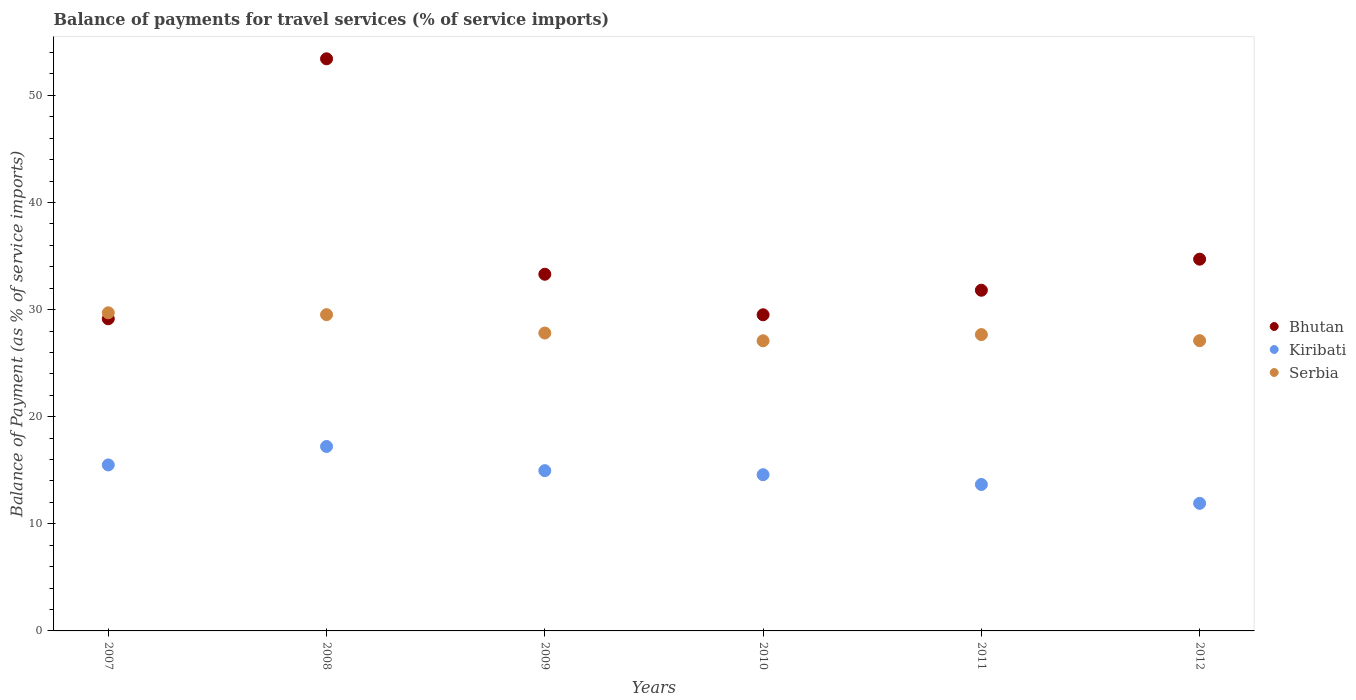How many different coloured dotlines are there?
Your answer should be compact. 3. What is the balance of payments for travel services in Serbia in 2010?
Your answer should be compact. 27.09. Across all years, what is the maximum balance of payments for travel services in Kiribati?
Provide a succinct answer. 17.22. Across all years, what is the minimum balance of payments for travel services in Kiribati?
Your answer should be very brief. 11.91. In which year was the balance of payments for travel services in Bhutan maximum?
Make the answer very short. 2008. What is the total balance of payments for travel services in Bhutan in the graph?
Provide a short and direct response. 211.89. What is the difference between the balance of payments for travel services in Serbia in 2007 and that in 2011?
Keep it short and to the point. 2.04. What is the difference between the balance of payments for travel services in Serbia in 2010 and the balance of payments for travel services in Bhutan in 2008?
Your answer should be very brief. -26.33. What is the average balance of payments for travel services in Bhutan per year?
Offer a very short reply. 35.31. In the year 2009, what is the difference between the balance of payments for travel services in Serbia and balance of payments for travel services in Bhutan?
Make the answer very short. -5.49. What is the ratio of the balance of payments for travel services in Bhutan in 2007 to that in 2012?
Make the answer very short. 0.84. What is the difference between the highest and the second highest balance of payments for travel services in Serbia?
Your response must be concise. 0.17. What is the difference between the highest and the lowest balance of payments for travel services in Kiribati?
Keep it short and to the point. 5.31. In how many years, is the balance of payments for travel services in Serbia greater than the average balance of payments for travel services in Serbia taken over all years?
Your answer should be very brief. 2. Does the balance of payments for travel services in Serbia monotonically increase over the years?
Your response must be concise. No. Is the balance of payments for travel services in Bhutan strictly less than the balance of payments for travel services in Kiribati over the years?
Offer a very short reply. No. How many dotlines are there?
Make the answer very short. 3. What is the difference between two consecutive major ticks on the Y-axis?
Your answer should be very brief. 10. Where does the legend appear in the graph?
Keep it short and to the point. Center right. How are the legend labels stacked?
Provide a succinct answer. Vertical. What is the title of the graph?
Offer a very short reply. Balance of payments for travel services (% of service imports). What is the label or title of the Y-axis?
Your answer should be very brief. Balance of Payment (as % of service imports). What is the Balance of Payment (as % of service imports) of Bhutan in 2007?
Make the answer very short. 29.14. What is the Balance of Payment (as % of service imports) in Kiribati in 2007?
Keep it short and to the point. 15.5. What is the Balance of Payment (as % of service imports) of Serbia in 2007?
Keep it short and to the point. 29.7. What is the Balance of Payment (as % of service imports) of Bhutan in 2008?
Give a very brief answer. 53.42. What is the Balance of Payment (as % of service imports) in Kiribati in 2008?
Provide a short and direct response. 17.22. What is the Balance of Payment (as % of service imports) of Serbia in 2008?
Give a very brief answer. 29.53. What is the Balance of Payment (as % of service imports) in Bhutan in 2009?
Give a very brief answer. 33.3. What is the Balance of Payment (as % of service imports) in Kiribati in 2009?
Provide a short and direct response. 14.96. What is the Balance of Payment (as % of service imports) of Serbia in 2009?
Ensure brevity in your answer.  27.81. What is the Balance of Payment (as % of service imports) in Bhutan in 2010?
Make the answer very short. 29.52. What is the Balance of Payment (as % of service imports) in Kiribati in 2010?
Ensure brevity in your answer.  14.58. What is the Balance of Payment (as % of service imports) in Serbia in 2010?
Your response must be concise. 27.09. What is the Balance of Payment (as % of service imports) in Bhutan in 2011?
Make the answer very short. 31.81. What is the Balance of Payment (as % of service imports) in Kiribati in 2011?
Give a very brief answer. 13.67. What is the Balance of Payment (as % of service imports) of Serbia in 2011?
Your response must be concise. 27.67. What is the Balance of Payment (as % of service imports) in Bhutan in 2012?
Offer a very short reply. 34.71. What is the Balance of Payment (as % of service imports) of Kiribati in 2012?
Give a very brief answer. 11.91. What is the Balance of Payment (as % of service imports) of Serbia in 2012?
Ensure brevity in your answer.  27.1. Across all years, what is the maximum Balance of Payment (as % of service imports) of Bhutan?
Your response must be concise. 53.42. Across all years, what is the maximum Balance of Payment (as % of service imports) in Kiribati?
Offer a very short reply. 17.22. Across all years, what is the maximum Balance of Payment (as % of service imports) in Serbia?
Your response must be concise. 29.7. Across all years, what is the minimum Balance of Payment (as % of service imports) in Bhutan?
Give a very brief answer. 29.14. Across all years, what is the minimum Balance of Payment (as % of service imports) in Kiribati?
Ensure brevity in your answer.  11.91. Across all years, what is the minimum Balance of Payment (as % of service imports) in Serbia?
Ensure brevity in your answer.  27.09. What is the total Balance of Payment (as % of service imports) in Bhutan in the graph?
Your answer should be very brief. 211.89. What is the total Balance of Payment (as % of service imports) in Kiribati in the graph?
Your answer should be compact. 87.85. What is the total Balance of Payment (as % of service imports) of Serbia in the graph?
Provide a succinct answer. 168.89. What is the difference between the Balance of Payment (as % of service imports) of Bhutan in 2007 and that in 2008?
Give a very brief answer. -24.27. What is the difference between the Balance of Payment (as % of service imports) in Kiribati in 2007 and that in 2008?
Provide a short and direct response. -1.72. What is the difference between the Balance of Payment (as % of service imports) in Serbia in 2007 and that in 2008?
Keep it short and to the point. 0.17. What is the difference between the Balance of Payment (as % of service imports) of Bhutan in 2007 and that in 2009?
Provide a short and direct response. -4.16. What is the difference between the Balance of Payment (as % of service imports) of Kiribati in 2007 and that in 2009?
Your answer should be compact. 0.53. What is the difference between the Balance of Payment (as % of service imports) in Serbia in 2007 and that in 2009?
Your answer should be very brief. 1.89. What is the difference between the Balance of Payment (as % of service imports) of Bhutan in 2007 and that in 2010?
Make the answer very short. -0.37. What is the difference between the Balance of Payment (as % of service imports) in Kiribati in 2007 and that in 2010?
Provide a short and direct response. 0.91. What is the difference between the Balance of Payment (as % of service imports) of Serbia in 2007 and that in 2010?
Ensure brevity in your answer.  2.61. What is the difference between the Balance of Payment (as % of service imports) of Bhutan in 2007 and that in 2011?
Make the answer very short. -2.67. What is the difference between the Balance of Payment (as % of service imports) in Kiribati in 2007 and that in 2011?
Keep it short and to the point. 1.83. What is the difference between the Balance of Payment (as % of service imports) of Serbia in 2007 and that in 2011?
Provide a short and direct response. 2.04. What is the difference between the Balance of Payment (as % of service imports) in Bhutan in 2007 and that in 2012?
Offer a terse response. -5.57. What is the difference between the Balance of Payment (as % of service imports) in Kiribati in 2007 and that in 2012?
Offer a terse response. 3.59. What is the difference between the Balance of Payment (as % of service imports) of Serbia in 2007 and that in 2012?
Provide a short and direct response. 2.6. What is the difference between the Balance of Payment (as % of service imports) of Bhutan in 2008 and that in 2009?
Your answer should be very brief. 20.11. What is the difference between the Balance of Payment (as % of service imports) of Kiribati in 2008 and that in 2009?
Make the answer very short. 2.26. What is the difference between the Balance of Payment (as % of service imports) of Serbia in 2008 and that in 2009?
Give a very brief answer. 1.71. What is the difference between the Balance of Payment (as % of service imports) of Bhutan in 2008 and that in 2010?
Give a very brief answer. 23.9. What is the difference between the Balance of Payment (as % of service imports) in Kiribati in 2008 and that in 2010?
Provide a short and direct response. 2.64. What is the difference between the Balance of Payment (as % of service imports) in Serbia in 2008 and that in 2010?
Your answer should be compact. 2.44. What is the difference between the Balance of Payment (as % of service imports) of Bhutan in 2008 and that in 2011?
Give a very brief answer. 21.61. What is the difference between the Balance of Payment (as % of service imports) of Kiribati in 2008 and that in 2011?
Provide a short and direct response. 3.55. What is the difference between the Balance of Payment (as % of service imports) in Serbia in 2008 and that in 2011?
Make the answer very short. 1.86. What is the difference between the Balance of Payment (as % of service imports) of Bhutan in 2008 and that in 2012?
Your answer should be compact. 18.71. What is the difference between the Balance of Payment (as % of service imports) of Kiribati in 2008 and that in 2012?
Provide a succinct answer. 5.31. What is the difference between the Balance of Payment (as % of service imports) of Serbia in 2008 and that in 2012?
Keep it short and to the point. 2.43. What is the difference between the Balance of Payment (as % of service imports) in Bhutan in 2009 and that in 2010?
Your answer should be very brief. 3.78. What is the difference between the Balance of Payment (as % of service imports) in Kiribati in 2009 and that in 2010?
Offer a very short reply. 0.38. What is the difference between the Balance of Payment (as % of service imports) of Serbia in 2009 and that in 2010?
Your answer should be very brief. 0.73. What is the difference between the Balance of Payment (as % of service imports) in Bhutan in 2009 and that in 2011?
Your answer should be very brief. 1.49. What is the difference between the Balance of Payment (as % of service imports) of Kiribati in 2009 and that in 2011?
Your answer should be very brief. 1.29. What is the difference between the Balance of Payment (as % of service imports) of Serbia in 2009 and that in 2011?
Give a very brief answer. 0.15. What is the difference between the Balance of Payment (as % of service imports) of Bhutan in 2009 and that in 2012?
Provide a short and direct response. -1.41. What is the difference between the Balance of Payment (as % of service imports) of Kiribati in 2009 and that in 2012?
Your response must be concise. 3.05. What is the difference between the Balance of Payment (as % of service imports) of Serbia in 2009 and that in 2012?
Keep it short and to the point. 0.71. What is the difference between the Balance of Payment (as % of service imports) in Bhutan in 2010 and that in 2011?
Ensure brevity in your answer.  -2.29. What is the difference between the Balance of Payment (as % of service imports) in Kiribati in 2010 and that in 2011?
Make the answer very short. 0.91. What is the difference between the Balance of Payment (as % of service imports) in Serbia in 2010 and that in 2011?
Offer a terse response. -0.58. What is the difference between the Balance of Payment (as % of service imports) of Bhutan in 2010 and that in 2012?
Give a very brief answer. -5.19. What is the difference between the Balance of Payment (as % of service imports) of Kiribati in 2010 and that in 2012?
Provide a succinct answer. 2.67. What is the difference between the Balance of Payment (as % of service imports) in Serbia in 2010 and that in 2012?
Make the answer very short. -0.01. What is the difference between the Balance of Payment (as % of service imports) in Bhutan in 2011 and that in 2012?
Give a very brief answer. -2.9. What is the difference between the Balance of Payment (as % of service imports) of Kiribati in 2011 and that in 2012?
Keep it short and to the point. 1.76. What is the difference between the Balance of Payment (as % of service imports) in Serbia in 2011 and that in 2012?
Your response must be concise. 0.57. What is the difference between the Balance of Payment (as % of service imports) of Bhutan in 2007 and the Balance of Payment (as % of service imports) of Kiribati in 2008?
Offer a very short reply. 11.92. What is the difference between the Balance of Payment (as % of service imports) of Bhutan in 2007 and the Balance of Payment (as % of service imports) of Serbia in 2008?
Give a very brief answer. -0.39. What is the difference between the Balance of Payment (as % of service imports) in Kiribati in 2007 and the Balance of Payment (as % of service imports) in Serbia in 2008?
Provide a succinct answer. -14.03. What is the difference between the Balance of Payment (as % of service imports) in Bhutan in 2007 and the Balance of Payment (as % of service imports) in Kiribati in 2009?
Offer a very short reply. 14.18. What is the difference between the Balance of Payment (as % of service imports) in Bhutan in 2007 and the Balance of Payment (as % of service imports) in Serbia in 2009?
Make the answer very short. 1.33. What is the difference between the Balance of Payment (as % of service imports) of Kiribati in 2007 and the Balance of Payment (as % of service imports) of Serbia in 2009?
Your answer should be compact. -12.32. What is the difference between the Balance of Payment (as % of service imports) of Bhutan in 2007 and the Balance of Payment (as % of service imports) of Kiribati in 2010?
Your answer should be very brief. 14.56. What is the difference between the Balance of Payment (as % of service imports) of Bhutan in 2007 and the Balance of Payment (as % of service imports) of Serbia in 2010?
Your answer should be very brief. 2.05. What is the difference between the Balance of Payment (as % of service imports) of Kiribati in 2007 and the Balance of Payment (as % of service imports) of Serbia in 2010?
Ensure brevity in your answer.  -11.59. What is the difference between the Balance of Payment (as % of service imports) of Bhutan in 2007 and the Balance of Payment (as % of service imports) of Kiribati in 2011?
Ensure brevity in your answer.  15.47. What is the difference between the Balance of Payment (as % of service imports) in Bhutan in 2007 and the Balance of Payment (as % of service imports) in Serbia in 2011?
Ensure brevity in your answer.  1.48. What is the difference between the Balance of Payment (as % of service imports) in Kiribati in 2007 and the Balance of Payment (as % of service imports) in Serbia in 2011?
Offer a very short reply. -12.17. What is the difference between the Balance of Payment (as % of service imports) of Bhutan in 2007 and the Balance of Payment (as % of service imports) of Kiribati in 2012?
Make the answer very short. 17.23. What is the difference between the Balance of Payment (as % of service imports) in Bhutan in 2007 and the Balance of Payment (as % of service imports) in Serbia in 2012?
Offer a terse response. 2.04. What is the difference between the Balance of Payment (as % of service imports) in Kiribati in 2007 and the Balance of Payment (as % of service imports) in Serbia in 2012?
Make the answer very short. -11.6. What is the difference between the Balance of Payment (as % of service imports) in Bhutan in 2008 and the Balance of Payment (as % of service imports) in Kiribati in 2009?
Provide a short and direct response. 38.45. What is the difference between the Balance of Payment (as % of service imports) in Bhutan in 2008 and the Balance of Payment (as % of service imports) in Serbia in 2009?
Offer a very short reply. 25.6. What is the difference between the Balance of Payment (as % of service imports) of Kiribati in 2008 and the Balance of Payment (as % of service imports) of Serbia in 2009?
Your answer should be compact. -10.59. What is the difference between the Balance of Payment (as % of service imports) in Bhutan in 2008 and the Balance of Payment (as % of service imports) in Kiribati in 2010?
Your response must be concise. 38.83. What is the difference between the Balance of Payment (as % of service imports) of Bhutan in 2008 and the Balance of Payment (as % of service imports) of Serbia in 2010?
Keep it short and to the point. 26.33. What is the difference between the Balance of Payment (as % of service imports) of Kiribati in 2008 and the Balance of Payment (as % of service imports) of Serbia in 2010?
Provide a short and direct response. -9.87. What is the difference between the Balance of Payment (as % of service imports) of Bhutan in 2008 and the Balance of Payment (as % of service imports) of Kiribati in 2011?
Ensure brevity in your answer.  39.74. What is the difference between the Balance of Payment (as % of service imports) in Bhutan in 2008 and the Balance of Payment (as % of service imports) in Serbia in 2011?
Your response must be concise. 25.75. What is the difference between the Balance of Payment (as % of service imports) in Kiribati in 2008 and the Balance of Payment (as % of service imports) in Serbia in 2011?
Ensure brevity in your answer.  -10.44. What is the difference between the Balance of Payment (as % of service imports) of Bhutan in 2008 and the Balance of Payment (as % of service imports) of Kiribati in 2012?
Offer a very short reply. 41.51. What is the difference between the Balance of Payment (as % of service imports) of Bhutan in 2008 and the Balance of Payment (as % of service imports) of Serbia in 2012?
Your response must be concise. 26.32. What is the difference between the Balance of Payment (as % of service imports) in Kiribati in 2008 and the Balance of Payment (as % of service imports) in Serbia in 2012?
Provide a short and direct response. -9.88. What is the difference between the Balance of Payment (as % of service imports) in Bhutan in 2009 and the Balance of Payment (as % of service imports) in Kiribati in 2010?
Your answer should be very brief. 18.72. What is the difference between the Balance of Payment (as % of service imports) in Bhutan in 2009 and the Balance of Payment (as % of service imports) in Serbia in 2010?
Provide a short and direct response. 6.21. What is the difference between the Balance of Payment (as % of service imports) of Kiribati in 2009 and the Balance of Payment (as % of service imports) of Serbia in 2010?
Your response must be concise. -12.12. What is the difference between the Balance of Payment (as % of service imports) in Bhutan in 2009 and the Balance of Payment (as % of service imports) in Kiribati in 2011?
Your answer should be very brief. 19.63. What is the difference between the Balance of Payment (as % of service imports) of Bhutan in 2009 and the Balance of Payment (as % of service imports) of Serbia in 2011?
Make the answer very short. 5.63. What is the difference between the Balance of Payment (as % of service imports) of Kiribati in 2009 and the Balance of Payment (as % of service imports) of Serbia in 2011?
Offer a terse response. -12.7. What is the difference between the Balance of Payment (as % of service imports) in Bhutan in 2009 and the Balance of Payment (as % of service imports) in Kiribati in 2012?
Provide a succinct answer. 21.39. What is the difference between the Balance of Payment (as % of service imports) in Bhutan in 2009 and the Balance of Payment (as % of service imports) in Serbia in 2012?
Keep it short and to the point. 6.2. What is the difference between the Balance of Payment (as % of service imports) of Kiribati in 2009 and the Balance of Payment (as % of service imports) of Serbia in 2012?
Keep it short and to the point. -12.14. What is the difference between the Balance of Payment (as % of service imports) in Bhutan in 2010 and the Balance of Payment (as % of service imports) in Kiribati in 2011?
Your answer should be compact. 15.84. What is the difference between the Balance of Payment (as % of service imports) in Bhutan in 2010 and the Balance of Payment (as % of service imports) in Serbia in 2011?
Your answer should be very brief. 1.85. What is the difference between the Balance of Payment (as % of service imports) of Kiribati in 2010 and the Balance of Payment (as % of service imports) of Serbia in 2011?
Provide a short and direct response. -13.08. What is the difference between the Balance of Payment (as % of service imports) of Bhutan in 2010 and the Balance of Payment (as % of service imports) of Kiribati in 2012?
Offer a terse response. 17.61. What is the difference between the Balance of Payment (as % of service imports) of Bhutan in 2010 and the Balance of Payment (as % of service imports) of Serbia in 2012?
Your response must be concise. 2.42. What is the difference between the Balance of Payment (as % of service imports) in Kiribati in 2010 and the Balance of Payment (as % of service imports) in Serbia in 2012?
Offer a very short reply. -12.52. What is the difference between the Balance of Payment (as % of service imports) in Bhutan in 2011 and the Balance of Payment (as % of service imports) in Kiribati in 2012?
Your response must be concise. 19.9. What is the difference between the Balance of Payment (as % of service imports) in Bhutan in 2011 and the Balance of Payment (as % of service imports) in Serbia in 2012?
Your response must be concise. 4.71. What is the difference between the Balance of Payment (as % of service imports) of Kiribati in 2011 and the Balance of Payment (as % of service imports) of Serbia in 2012?
Ensure brevity in your answer.  -13.43. What is the average Balance of Payment (as % of service imports) in Bhutan per year?
Offer a terse response. 35.31. What is the average Balance of Payment (as % of service imports) of Kiribati per year?
Offer a terse response. 14.64. What is the average Balance of Payment (as % of service imports) in Serbia per year?
Provide a succinct answer. 28.15. In the year 2007, what is the difference between the Balance of Payment (as % of service imports) of Bhutan and Balance of Payment (as % of service imports) of Kiribati?
Your response must be concise. 13.64. In the year 2007, what is the difference between the Balance of Payment (as % of service imports) in Bhutan and Balance of Payment (as % of service imports) in Serbia?
Your answer should be very brief. -0.56. In the year 2007, what is the difference between the Balance of Payment (as % of service imports) of Kiribati and Balance of Payment (as % of service imports) of Serbia?
Offer a very short reply. -14.2. In the year 2008, what is the difference between the Balance of Payment (as % of service imports) in Bhutan and Balance of Payment (as % of service imports) in Kiribati?
Your answer should be compact. 36.19. In the year 2008, what is the difference between the Balance of Payment (as % of service imports) of Bhutan and Balance of Payment (as % of service imports) of Serbia?
Offer a terse response. 23.89. In the year 2008, what is the difference between the Balance of Payment (as % of service imports) in Kiribati and Balance of Payment (as % of service imports) in Serbia?
Provide a succinct answer. -12.31. In the year 2009, what is the difference between the Balance of Payment (as % of service imports) of Bhutan and Balance of Payment (as % of service imports) of Kiribati?
Provide a short and direct response. 18.34. In the year 2009, what is the difference between the Balance of Payment (as % of service imports) of Bhutan and Balance of Payment (as % of service imports) of Serbia?
Ensure brevity in your answer.  5.49. In the year 2009, what is the difference between the Balance of Payment (as % of service imports) of Kiribati and Balance of Payment (as % of service imports) of Serbia?
Provide a short and direct response. -12.85. In the year 2010, what is the difference between the Balance of Payment (as % of service imports) in Bhutan and Balance of Payment (as % of service imports) in Kiribati?
Keep it short and to the point. 14.93. In the year 2010, what is the difference between the Balance of Payment (as % of service imports) of Bhutan and Balance of Payment (as % of service imports) of Serbia?
Give a very brief answer. 2.43. In the year 2010, what is the difference between the Balance of Payment (as % of service imports) in Kiribati and Balance of Payment (as % of service imports) in Serbia?
Provide a succinct answer. -12.5. In the year 2011, what is the difference between the Balance of Payment (as % of service imports) in Bhutan and Balance of Payment (as % of service imports) in Kiribati?
Your answer should be very brief. 18.13. In the year 2011, what is the difference between the Balance of Payment (as % of service imports) in Bhutan and Balance of Payment (as % of service imports) in Serbia?
Give a very brief answer. 4.14. In the year 2011, what is the difference between the Balance of Payment (as % of service imports) in Kiribati and Balance of Payment (as % of service imports) in Serbia?
Provide a succinct answer. -13.99. In the year 2012, what is the difference between the Balance of Payment (as % of service imports) in Bhutan and Balance of Payment (as % of service imports) in Kiribati?
Offer a terse response. 22.8. In the year 2012, what is the difference between the Balance of Payment (as % of service imports) in Bhutan and Balance of Payment (as % of service imports) in Serbia?
Offer a terse response. 7.61. In the year 2012, what is the difference between the Balance of Payment (as % of service imports) of Kiribati and Balance of Payment (as % of service imports) of Serbia?
Provide a short and direct response. -15.19. What is the ratio of the Balance of Payment (as % of service imports) in Bhutan in 2007 to that in 2008?
Give a very brief answer. 0.55. What is the ratio of the Balance of Payment (as % of service imports) of Kiribati in 2007 to that in 2008?
Provide a succinct answer. 0.9. What is the ratio of the Balance of Payment (as % of service imports) in Serbia in 2007 to that in 2008?
Your response must be concise. 1.01. What is the ratio of the Balance of Payment (as % of service imports) in Bhutan in 2007 to that in 2009?
Offer a terse response. 0.88. What is the ratio of the Balance of Payment (as % of service imports) in Kiribati in 2007 to that in 2009?
Make the answer very short. 1.04. What is the ratio of the Balance of Payment (as % of service imports) in Serbia in 2007 to that in 2009?
Provide a succinct answer. 1.07. What is the ratio of the Balance of Payment (as % of service imports) in Bhutan in 2007 to that in 2010?
Keep it short and to the point. 0.99. What is the ratio of the Balance of Payment (as % of service imports) in Kiribati in 2007 to that in 2010?
Give a very brief answer. 1.06. What is the ratio of the Balance of Payment (as % of service imports) of Serbia in 2007 to that in 2010?
Your answer should be compact. 1.1. What is the ratio of the Balance of Payment (as % of service imports) of Bhutan in 2007 to that in 2011?
Provide a short and direct response. 0.92. What is the ratio of the Balance of Payment (as % of service imports) of Kiribati in 2007 to that in 2011?
Your answer should be very brief. 1.13. What is the ratio of the Balance of Payment (as % of service imports) in Serbia in 2007 to that in 2011?
Provide a short and direct response. 1.07. What is the ratio of the Balance of Payment (as % of service imports) in Bhutan in 2007 to that in 2012?
Your answer should be very brief. 0.84. What is the ratio of the Balance of Payment (as % of service imports) of Kiribati in 2007 to that in 2012?
Keep it short and to the point. 1.3. What is the ratio of the Balance of Payment (as % of service imports) of Serbia in 2007 to that in 2012?
Your response must be concise. 1.1. What is the ratio of the Balance of Payment (as % of service imports) in Bhutan in 2008 to that in 2009?
Offer a very short reply. 1.6. What is the ratio of the Balance of Payment (as % of service imports) in Kiribati in 2008 to that in 2009?
Keep it short and to the point. 1.15. What is the ratio of the Balance of Payment (as % of service imports) in Serbia in 2008 to that in 2009?
Offer a very short reply. 1.06. What is the ratio of the Balance of Payment (as % of service imports) in Bhutan in 2008 to that in 2010?
Provide a succinct answer. 1.81. What is the ratio of the Balance of Payment (as % of service imports) of Kiribati in 2008 to that in 2010?
Your answer should be very brief. 1.18. What is the ratio of the Balance of Payment (as % of service imports) of Serbia in 2008 to that in 2010?
Your answer should be compact. 1.09. What is the ratio of the Balance of Payment (as % of service imports) in Bhutan in 2008 to that in 2011?
Your answer should be very brief. 1.68. What is the ratio of the Balance of Payment (as % of service imports) of Kiribati in 2008 to that in 2011?
Offer a very short reply. 1.26. What is the ratio of the Balance of Payment (as % of service imports) in Serbia in 2008 to that in 2011?
Your answer should be compact. 1.07. What is the ratio of the Balance of Payment (as % of service imports) of Bhutan in 2008 to that in 2012?
Your answer should be very brief. 1.54. What is the ratio of the Balance of Payment (as % of service imports) in Kiribati in 2008 to that in 2012?
Ensure brevity in your answer.  1.45. What is the ratio of the Balance of Payment (as % of service imports) in Serbia in 2008 to that in 2012?
Your response must be concise. 1.09. What is the ratio of the Balance of Payment (as % of service imports) in Bhutan in 2009 to that in 2010?
Provide a short and direct response. 1.13. What is the ratio of the Balance of Payment (as % of service imports) of Serbia in 2009 to that in 2010?
Offer a very short reply. 1.03. What is the ratio of the Balance of Payment (as % of service imports) in Bhutan in 2009 to that in 2011?
Give a very brief answer. 1.05. What is the ratio of the Balance of Payment (as % of service imports) in Kiribati in 2009 to that in 2011?
Keep it short and to the point. 1.09. What is the ratio of the Balance of Payment (as % of service imports) of Serbia in 2009 to that in 2011?
Ensure brevity in your answer.  1.01. What is the ratio of the Balance of Payment (as % of service imports) of Bhutan in 2009 to that in 2012?
Offer a terse response. 0.96. What is the ratio of the Balance of Payment (as % of service imports) in Kiribati in 2009 to that in 2012?
Ensure brevity in your answer.  1.26. What is the ratio of the Balance of Payment (as % of service imports) of Serbia in 2009 to that in 2012?
Your answer should be compact. 1.03. What is the ratio of the Balance of Payment (as % of service imports) in Bhutan in 2010 to that in 2011?
Your answer should be very brief. 0.93. What is the ratio of the Balance of Payment (as % of service imports) of Kiribati in 2010 to that in 2011?
Ensure brevity in your answer.  1.07. What is the ratio of the Balance of Payment (as % of service imports) of Serbia in 2010 to that in 2011?
Your answer should be compact. 0.98. What is the ratio of the Balance of Payment (as % of service imports) in Bhutan in 2010 to that in 2012?
Your response must be concise. 0.85. What is the ratio of the Balance of Payment (as % of service imports) in Kiribati in 2010 to that in 2012?
Give a very brief answer. 1.22. What is the ratio of the Balance of Payment (as % of service imports) of Serbia in 2010 to that in 2012?
Your answer should be very brief. 1. What is the ratio of the Balance of Payment (as % of service imports) in Bhutan in 2011 to that in 2012?
Keep it short and to the point. 0.92. What is the ratio of the Balance of Payment (as % of service imports) in Kiribati in 2011 to that in 2012?
Make the answer very short. 1.15. What is the ratio of the Balance of Payment (as % of service imports) of Serbia in 2011 to that in 2012?
Offer a very short reply. 1.02. What is the difference between the highest and the second highest Balance of Payment (as % of service imports) in Bhutan?
Provide a short and direct response. 18.71. What is the difference between the highest and the second highest Balance of Payment (as % of service imports) of Kiribati?
Offer a very short reply. 1.72. What is the difference between the highest and the second highest Balance of Payment (as % of service imports) of Serbia?
Your answer should be compact. 0.17. What is the difference between the highest and the lowest Balance of Payment (as % of service imports) in Bhutan?
Provide a short and direct response. 24.27. What is the difference between the highest and the lowest Balance of Payment (as % of service imports) of Kiribati?
Provide a succinct answer. 5.31. What is the difference between the highest and the lowest Balance of Payment (as % of service imports) of Serbia?
Give a very brief answer. 2.61. 